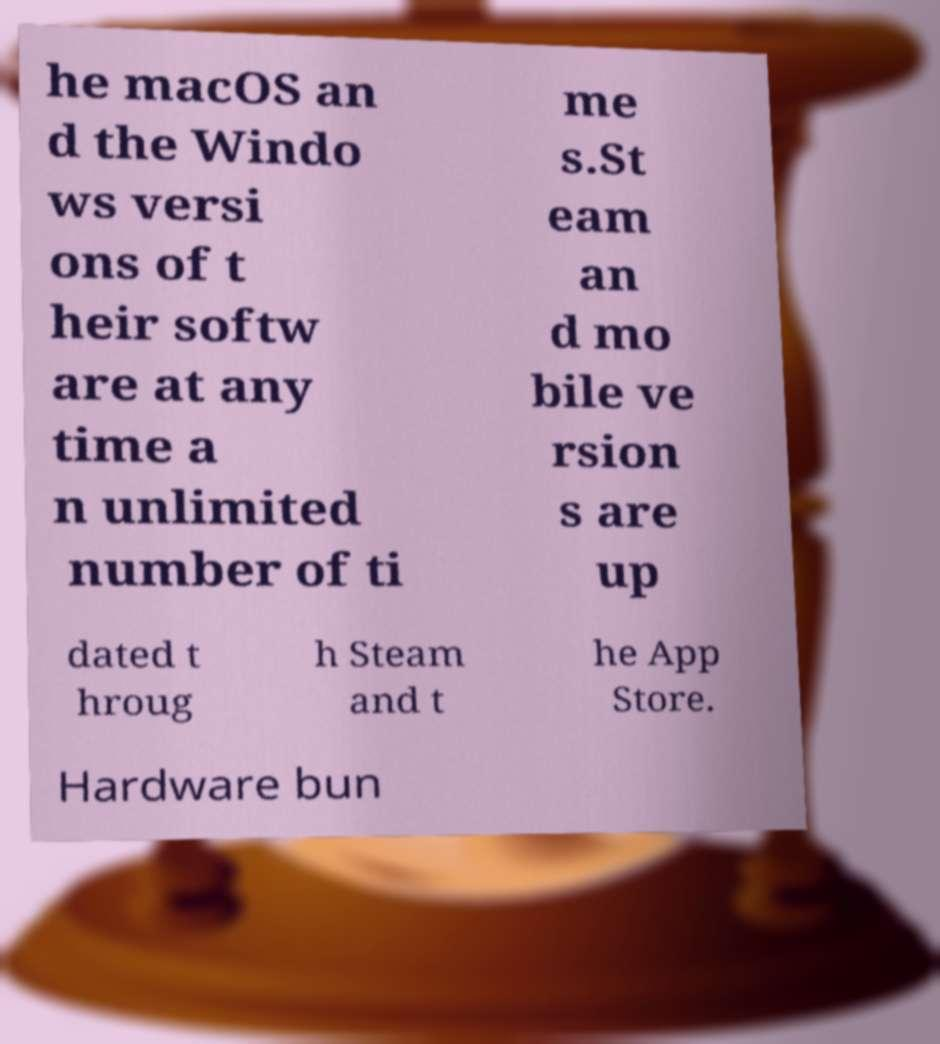Can you accurately transcribe the text from the provided image for me? he macOS an d the Windo ws versi ons of t heir softw are at any time a n unlimited number of ti me s.St eam an d mo bile ve rsion s are up dated t hroug h Steam and t he App Store. Hardware bun 